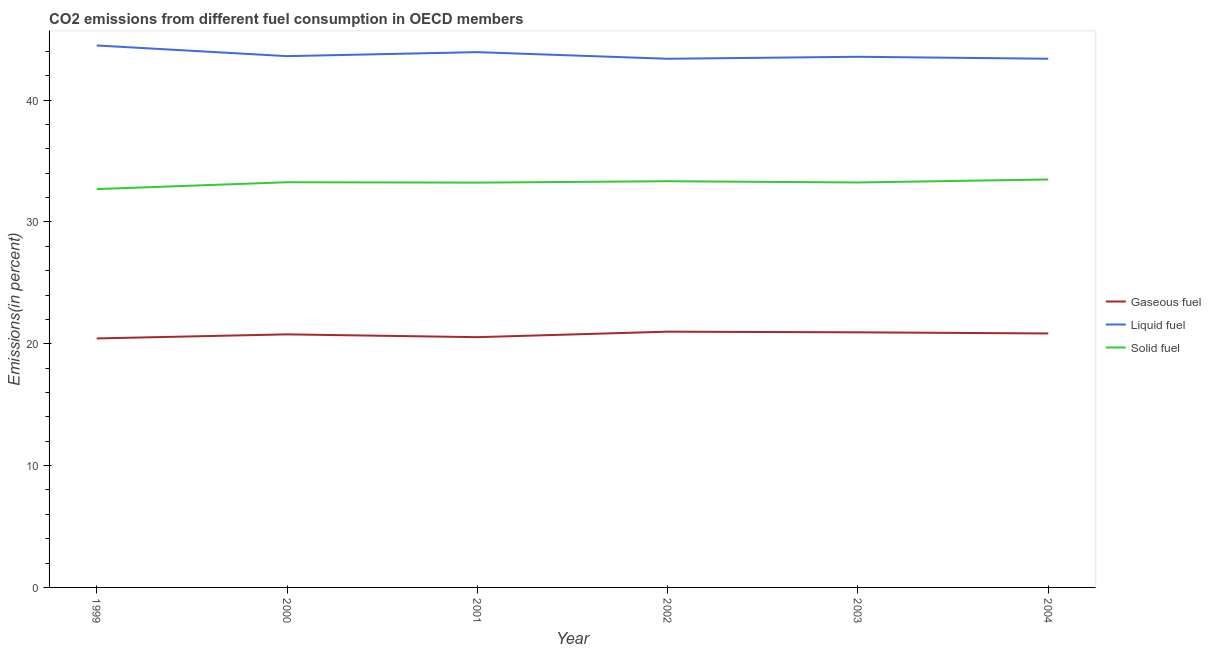What is the percentage of liquid fuel emission in 2002?
Your answer should be compact. 43.39. Across all years, what is the maximum percentage of solid fuel emission?
Offer a very short reply. 33.48. Across all years, what is the minimum percentage of liquid fuel emission?
Your response must be concise. 43.39. In which year was the percentage of solid fuel emission maximum?
Give a very brief answer. 2004. What is the total percentage of liquid fuel emission in the graph?
Keep it short and to the point. 262.35. What is the difference between the percentage of solid fuel emission in 2002 and that in 2003?
Keep it short and to the point. 0.1. What is the difference between the percentage of solid fuel emission in 2001 and the percentage of liquid fuel emission in 2002?
Offer a terse response. -10.17. What is the average percentage of gaseous fuel emission per year?
Provide a short and direct response. 20.75. In the year 1999, what is the difference between the percentage of liquid fuel emission and percentage of gaseous fuel emission?
Provide a short and direct response. 24.04. In how many years, is the percentage of liquid fuel emission greater than 14 %?
Ensure brevity in your answer.  6. What is the ratio of the percentage of liquid fuel emission in 2002 to that in 2003?
Offer a terse response. 1. Is the percentage of solid fuel emission in 2001 less than that in 2003?
Provide a short and direct response. Yes. What is the difference between the highest and the second highest percentage of solid fuel emission?
Your answer should be very brief. 0.14. What is the difference between the highest and the lowest percentage of solid fuel emission?
Ensure brevity in your answer.  0.79. In how many years, is the percentage of solid fuel emission greater than the average percentage of solid fuel emission taken over all years?
Provide a succinct answer. 5. Is it the case that in every year, the sum of the percentage of gaseous fuel emission and percentage of liquid fuel emission is greater than the percentage of solid fuel emission?
Your answer should be very brief. Yes. Does the percentage of solid fuel emission monotonically increase over the years?
Your answer should be very brief. No. Is the percentage of solid fuel emission strictly greater than the percentage of gaseous fuel emission over the years?
Keep it short and to the point. Yes. How many lines are there?
Give a very brief answer. 3. How many years are there in the graph?
Make the answer very short. 6. How are the legend labels stacked?
Provide a succinct answer. Vertical. What is the title of the graph?
Give a very brief answer. CO2 emissions from different fuel consumption in OECD members. Does "Ages 15-64" appear as one of the legend labels in the graph?
Your answer should be very brief. No. What is the label or title of the X-axis?
Offer a very short reply. Year. What is the label or title of the Y-axis?
Provide a succinct answer. Emissions(in percent). What is the Emissions(in percent) in Gaseous fuel in 1999?
Your response must be concise. 20.44. What is the Emissions(in percent) in Liquid fuel in 1999?
Your answer should be very brief. 44.48. What is the Emissions(in percent) of Solid fuel in 1999?
Ensure brevity in your answer.  32.69. What is the Emissions(in percent) in Gaseous fuel in 2000?
Ensure brevity in your answer.  20.77. What is the Emissions(in percent) of Liquid fuel in 2000?
Offer a terse response. 43.61. What is the Emissions(in percent) in Solid fuel in 2000?
Ensure brevity in your answer.  33.26. What is the Emissions(in percent) in Gaseous fuel in 2001?
Your answer should be compact. 20.54. What is the Emissions(in percent) in Liquid fuel in 2001?
Provide a succinct answer. 43.93. What is the Emissions(in percent) in Solid fuel in 2001?
Give a very brief answer. 33.22. What is the Emissions(in percent) in Gaseous fuel in 2002?
Your answer should be very brief. 20.99. What is the Emissions(in percent) of Liquid fuel in 2002?
Provide a short and direct response. 43.39. What is the Emissions(in percent) in Solid fuel in 2002?
Your answer should be compact. 33.34. What is the Emissions(in percent) in Gaseous fuel in 2003?
Provide a short and direct response. 20.94. What is the Emissions(in percent) of Liquid fuel in 2003?
Keep it short and to the point. 43.55. What is the Emissions(in percent) of Solid fuel in 2003?
Your answer should be very brief. 33.24. What is the Emissions(in percent) in Gaseous fuel in 2004?
Keep it short and to the point. 20.84. What is the Emissions(in percent) in Liquid fuel in 2004?
Your response must be concise. 43.39. What is the Emissions(in percent) in Solid fuel in 2004?
Your answer should be compact. 33.48. Across all years, what is the maximum Emissions(in percent) of Gaseous fuel?
Your answer should be compact. 20.99. Across all years, what is the maximum Emissions(in percent) of Liquid fuel?
Give a very brief answer. 44.48. Across all years, what is the maximum Emissions(in percent) in Solid fuel?
Make the answer very short. 33.48. Across all years, what is the minimum Emissions(in percent) of Gaseous fuel?
Ensure brevity in your answer.  20.44. Across all years, what is the minimum Emissions(in percent) of Liquid fuel?
Ensure brevity in your answer.  43.39. Across all years, what is the minimum Emissions(in percent) of Solid fuel?
Your answer should be compact. 32.69. What is the total Emissions(in percent) in Gaseous fuel in the graph?
Provide a short and direct response. 124.52. What is the total Emissions(in percent) in Liquid fuel in the graph?
Give a very brief answer. 262.35. What is the total Emissions(in percent) of Solid fuel in the graph?
Provide a succinct answer. 199.23. What is the difference between the Emissions(in percent) in Gaseous fuel in 1999 and that in 2000?
Make the answer very short. -0.33. What is the difference between the Emissions(in percent) of Liquid fuel in 1999 and that in 2000?
Provide a short and direct response. 0.88. What is the difference between the Emissions(in percent) of Solid fuel in 1999 and that in 2000?
Keep it short and to the point. -0.56. What is the difference between the Emissions(in percent) in Gaseous fuel in 1999 and that in 2001?
Offer a terse response. -0.1. What is the difference between the Emissions(in percent) in Liquid fuel in 1999 and that in 2001?
Your response must be concise. 0.55. What is the difference between the Emissions(in percent) of Solid fuel in 1999 and that in 2001?
Offer a terse response. -0.53. What is the difference between the Emissions(in percent) of Gaseous fuel in 1999 and that in 2002?
Offer a very short reply. -0.55. What is the difference between the Emissions(in percent) of Liquid fuel in 1999 and that in 2002?
Provide a succinct answer. 1.09. What is the difference between the Emissions(in percent) of Solid fuel in 1999 and that in 2002?
Make the answer very short. -0.65. What is the difference between the Emissions(in percent) in Gaseous fuel in 1999 and that in 2003?
Offer a very short reply. -0.5. What is the difference between the Emissions(in percent) in Solid fuel in 1999 and that in 2003?
Provide a succinct answer. -0.54. What is the difference between the Emissions(in percent) in Gaseous fuel in 1999 and that in 2004?
Offer a very short reply. -0.41. What is the difference between the Emissions(in percent) in Liquid fuel in 1999 and that in 2004?
Your answer should be very brief. 1.09. What is the difference between the Emissions(in percent) of Solid fuel in 1999 and that in 2004?
Offer a very short reply. -0.79. What is the difference between the Emissions(in percent) of Gaseous fuel in 2000 and that in 2001?
Your response must be concise. 0.23. What is the difference between the Emissions(in percent) of Liquid fuel in 2000 and that in 2001?
Provide a short and direct response. -0.33. What is the difference between the Emissions(in percent) in Gaseous fuel in 2000 and that in 2002?
Offer a very short reply. -0.22. What is the difference between the Emissions(in percent) in Liquid fuel in 2000 and that in 2002?
Your answer should be compact. 0.22. What is the difference between the Emissions(in percent) of Solid fuel in 2000 and that in 2002?
Offer a very short reply. -0.08. What is the difference between the Emissions(in percent) of Gaseous fuel in 2000 and that in 2003?
Your answer should be compact. -0.17. What is the difference between the Emissions(in percent) in Liquid fuel in 2000 and that in 2003?
Ensure brevity in your answer.  0.05. What is the difference between the Emissions(in percent) of Solid fuel in 2000 and that in 2003?
Offer a terse response. 0.02. What is the difference between the Emissions(in percent) of Gaseous fuel in 2000 and that in 2004?
Your answer should be very brief. -0.07. What is the difference between the Emissions(in percent) of Liquid fuel in 2000 and that in 2004?
Your answer should be compact. 0.21. What is the difference between the Emissions(in percent) in Solid fuel in 2000 and that in 2004?
Give a very brief answer. -0.22. What is the difference between the Emissions(in percent) of Gaseous fuel in 2001 and that in 2002?
Your answer should be compact. -0.45. What is the difference between the Emissions(in percent) in Liquid fuel in 2001 and that in 2002?
Keep it short and to the point. 0.54. What is the difference between the Emissions(in percent) of Solid fuel in 2001 and that in 2002?
Give a very brief answer. -0.12. What is the difference between the Emissions(in percent) in Gaseous fuel in 2001 and that in 2003?
Keep it short and to the point. -0.4. What is the difference between the Emissions(in percent) in Liquid fuel in 2001 and that in 2003?
Offer a very short reply. 0.38. What is the difference between the Emissions(in percent) of Solid fuel in 2001 and that in 2003?
Make the answer very short. -0.01. What is the difference between the Emissions(in percent) in Gaseous fuel in 2001 and that in 2004?
Make the answer very short. -0.31. What is the difference between the Emissions(in percent) in Liquid fuel in 2001 and that in 2004?
Provide a succinct answer. 0.54. What is the difference between the Emissions(in percent) of Solid fuel in 2001 and that in 2004?
Offer a very short reply. -0.26. What is the difference between the Emissions(in percent) of Gaseous fuel in 2002 and that in 2003?
Provide a short and direct response. 0.05. What is the difference between the Emissions(in percent) in Liquid fuel in 2002 and that in 2003?
Offer a terse response. -0.16. What is the difference between the Emissions(in percent) of Solid fuel in 2002 and that in 2003?
Provide a short and direct response. 0.1. What is the difference between the Emissions(in percent) of Gaseous fuel in 2002 and that in 2004?
Make the answer very short. 0.15. What is the difference between the Emissions(in percent) in Liquid fuel in 2002 and that in 2004?
Offer a terse response. -0. What is the difference between the Emissions(in percent) in Solid fuel in 2002 and that in 2004?
Make the answer very short. -0.14. What is the difference between the Emissions(in percent) in Gaseous fuel in 2003 and that in 2004?
Your response must be concise. 0.09. What is the difference between the Emissions(in percent) of Liquid fuel in 2003 and that in 2004?
Give a very brief answer. 0.16. What is the difference between the Emissions(in percent) of Solid fuel in 2003 and that in 2004?
Provide a succinct answer. -0.25. What is the difference between the Emissions(in percent) of Gaseous fuel in 1999 and the Emissions(in percent) of Liquid fuel in 2000?
Offer a terse response. -23.17. What is the difference between the Emissions(in percent) of Gaseous fuel in 1999 and the Emissions(in percent) of Solid fuel in 2000?
Offer a very short reply. -12.82. What is the difference between the Emissions(in percent) of Liquid fuel in 1999 and the Emissions(in percent) of Solid fuel in 2000?
Provide a succinct answer. 11.22. What is the difference between the Emissions(in percent) of Gaseous fuel in 1999 and the Emissions(in percent) of Liquid fuel in 2001?
Your answer should be compact. -23.5. What is the difference between the Emissions(in percent) in Gaseous fuel in 1999 and the Emissions(in percent) in Solid fuel in 2001?
Offer a very short reply. -12.79. What is the difference between the Emissions(in percent) in Liquid fuel in 1999 and the Emissions(in percent) in Solid fuel in 2001?
Your response must be concise. 11.26. What is the difference between the Emissions(in percent) of Gaseous fuel in 1999 and the Emissions(in percent) of Liquid fuel in 2002?
Your answer should be compact. -22.95. What is the difference between the Emissions(in percent) in Gaseous fuel in 1999 and the Emissions(in percent) in Solid fuel in 2002?
Your answer should be very brief. -12.9. What is the difference between the Emissions(in percent) of Liquid fuel in 1999 and the Emissions(in percent) of Solid fuel in 2002?
Provide a succinct answer. 11.14. What is the difference between the Emissions(in percent) in Gaseous fuel in 1999 and the Emissions(in percent) in Liquid fuel in 2003?
Your response must be concise. -23.12. What is the difference between the Emissions(in percent) of Gaseous fuel in 1999 and the Emissions(in percent) of Solid fuel in 2003?
Offer a terse response. -12.8. What is the difference between the Emissions(in percent) in Liquid fuel in 1999 and the Emissions(in percent) in Solid fuel in 2003?
Offer a very short reply. 11.24. What is the difference between the Emissions(in percent) of Gaseous fuel in 1999 and the Emissions(in percent) of Liquid fuel in 2004?
Provide a short and direct response. -22.96. What is the difference between the Emissions(in percent) of Gaseous fuel in 1999 and the Emissions(in percent) of Solid fuel in 2004?
Offer a terse response. -13.05. What is the difference between the Emissions(in percent) in Liquid fuel in 1999 and the Emissions(in percent) in Solid fuel in 2004?
Offer a very short reply. 11. What is the difference between the Emissions(in percent) in Gaseous fuel in 2000 and the Emissions(in percent) in Liquid fuel in 2001?
Provide a short and direct response. -23.16. What is the difference between the Emissions(in percent) in Gaseous fuel in 2000 and the Emissions(in percent) in Solid fuel in 2001?
Your answer should be compact. -12.45. What is the difference between the Emissions(in percent) in Liquid fuel in 2000 and the Emissions(in percent) in Solid fuel in 2001?
Ensure brevity in your answer.  10.38. What is the difference between the Emissions(in percent) of Gaseous fuel in 2000 and the Emissions(in percent) of Liquid fuel in 2002?
Provide a succinct answer. -22.62. What is the difference between the Emissions(in percent) in Gaseous fuel in 2000 and the Emissions(in percent) in Solid fuel in 2002?
Offer a terse response. -12.57. What is the difference between the Emissions(in percent) in Liquid fuel in 2000 and the Emissions(in percent) in Solid fuel in 2002?
Ensure brevity in your answer.  10.27. What is the difference between the Emissions(in percent) of Gaseous fuel in 2000 and the Emissions(in percent) of Liquid fuel in 2003?
Your answer should be very brief. -22.78. What is the difference between the Emissions(in percent) of Gaseous fuel in 2000 and the Emissions(in percent) of Solid fuel in 2003?
Offer a very short reply. -12.47. What is the difference between the Emissions(in percent) of Liquid fuel in 2000 and the Emissions(in percent) of Solid fuel in 2003?
Give a very brief answer. 10.37. What is the difference between the Emissions(in percent) of Gaseous fuel in 2000 and the Emissions(in percent) of Liquid fuel in 2004?
Your response must be concise. -22.62. What is the difference between the Emissions(in percent) in Gaseous fuel in 2000 and the Emissions(in percent) in Solid fuel in 2004?
Your answer should be very brief. -12.71. What is the difference between the Emissions(in percent) in Liquid fuel in 2000 and the Emissions(in percent) in Solid fuel in 2004?
Offer a very short reply. 10.12. What is the difference between the Emissions(in percent) of Gaseous fuel in 2001 and the Emissions(in percent) of Liquid fuel in 2002?
Your answer should be very brief. -22.85. What is the difference between the Emissions(in percent) of Gaseous fuel in 2001 and the Emissions(in percent) of Solid fuel in 2002?
Give a very brief answer. -12.8. What is the difference between the Emissions(in percent) in Liquid fuel in 2001 and the Emissions(in percent) in Solid fuel in 2002?
Provide a short and direct response. 10.59. What is the difference between the Emissions(in percent) in Gaseous fuel in 2001 and the Emissions(in percent) in Liquid fuel in 2003?
Offer a terse response. -23.01. What is the difference between the Emissions(in percent) in Gaseous fuel in 2001 and the Emissions(in percent) in Solid fuel in 2003?
Keep it short and to the point. -12.7. What is the difference between the Emissions(in percent) of Liquid fuel in 2001 and the Emissions(in percent) of Solid fuel in 2003?
Keep it short and to the point. 10.7. What is the difference between the Emissions(in percent) of Gaseous fuel in 2001 and the Emissions(in percent) of Liquid fuel in 2004?
Offer a terse response. -22.85. What is the difference between the Emissions(in percent) in Gaseous fuel in 2001 and the Emissions(in percent) in Solid fuel in 2004?
Offer a very short reply. -12.94. What is the difference between the Emissions(in percent) of Liquid fuel in 2001 and the Emissions(in percent) of Solid fuel in 2004?
Make the answer very short. 10.45. What is the difference between the Emissions(in percent) of Gaseous fuel in 2002 and the Emissions(in percent) of Liquid fuel in 2003?
Keep it short and to the point. -22.56. What is the difference between the Emissions(in percent) in Gaseous fuel in 2002 and the Emissions(in percent) in Solid fuel in 2003?
Your answer should be very brief. -12.25. What is the difference between the Emissions(in percent) in Liquid fuel in 2002 and the Emissions(in percent) in Solid fuel in 2003?
Give a very brief answer. 10.15. What is the difference between the Emissions(in percent) in Gaseous fuel in 2002 and the Emissions(in percent) in Liquid fuel in 2004?
Offer a very short reply. -22.4. What is the difference between the Emissions(in percent) in Gaseous fuel in 2002 and the Emissions(in percent) in Solid fuel in 2004?
Provide a short and direct response. -12.49. What is the difference between the Emissions(in percent) in Liquid fuel in 2002 and the Emissions(in percent) in Solid fuel in 2004?
Give a very brief answer. 9.91. What is the difference between the Emissions(in percent) in Gaseous fuel in 2003 and the Emissions(in percent) in Liquid fuel in 2004?
Keep it short and to the point. -22.46. What is the difference between the Emissions(in percent) of Gaseous fuel in 2003 and the Emissions(in percent) of Solid fuel in 2004?
Your answer should be compact. -12.54. What is the difference between the Emissions(in percent) in Liquid fuel in 2003 and the Emissions(in percent) in Solid fuel in 2004?
Keep it short and to the point. 10.07. What is the average Emissions(in percent) of Gaseous fuel per year?
Make the answer very short. 20.75. What is the average Emissions(in percent) of Liquid fuel per year?
Offer a very short reply. 43.73. What is the average Emissions(in percent) in Solid fuel per year?
Your response must be concise. 33.21. In the year 1999, what is the difference between the Emissions(in percent) of Gaseous fuel and Emissions(in percent) of Liquid fuel?
Ensure brevity in your answer.  -24.04. In the year 1999, what is the difference between the Emissions(in percent) of Gaseous fuel and Emissions(in percent) of Solid fuel?
Keep it short and to the point. -12.26. In the year 1999, what is the difference between the Emissions(in percent) of Liquid fuel and Emissions(in percent) of Solid fuel?
Provide a succinct answer. 11.79. In the year 2000, what is the difference between the Emissions(in percent) of Gaseous fuel and Emissions(in percent) of Liquid fuel?
Keep it short and to the point. -22.84. In the year 2000, what is the difference between the Emissions(in percent) of Gaseous fuel and Emissions(in percent) of Solid fuel?
Ensure brevity in your answer.  -12.49. In the year 2000, what is the difference between the Emissions(in percent) in Liquid fuel and Emissions(in percent) in Solid fuel?
Offer a very short reply. 10.35. In the year 2001, what is the difference between the Emissions(in percent) of Gaseous fuel and Emissions(in percent) of Liquid fuel?
Keep it short and to the point. -23.39. In the year 2001, what is the difference between the Emissions(in percent) in Gaseous fuel and Emissions(in percent) in Solid fuel?
Provide a short and direct response. -12.68. In the year 2001, what is the difference between the Emissions(in percent) of Liquid fuel and Emissions(in percent) of Solid fuel?
Provide a succinct answer. 10.71. In the year 2002, what is the difference between the Emissions(in percent) of Gaseous fuel and Emissions(in percent) of Liquid fuel?
Provide a short and direct response. -22.4. In the year 2002, what is the difference between the Emissions(in percent) of Gaseous fuel and Emissions(in percent) of Solid fuel?
Your answer should be very brief. -12.35. In the year 2002, what is the difference between the Emissions(in percent) of Liquid fuel and Emissions(in percent) of Solid fuel?
Your answer should be compact. 10.05. In the year 2003, what is the difference between the Emissions(in percent) in Gaseous fuel and Emissions(in percent) in Liquid fuel?
Provide a short and direct response. -22.62. In the year 2003, what is the difference between the Emissions(in percent) in Gaseous fuel and Emissions(in percent) in Solid fuel?
Offer a very short reply. -12.3. In the year 2003, what is the difference between the Emissions(in percent) in Liquid fuel and Emissions(in percent) in Solid fuel?
Offer a very short reply. 10.32. In the year 2004, what is the difference between the Emissions(in percent) of Gaseous fuel and Emissions(in percent) of Liquid fuel?
Offer a terse response. -22.55. In the year 2004, what is the difference between the Emissions(in percent) of Gaseous fuel and Emissions(in percent) of Solid fuel?
Keep it short and to the point. -12.64. In the year 2004, what is the difference between the Emissions(in percent) in Liquid fuel and Emissions(in percent) in Solid fuel?
Ensure brevity in your answer.  9.91. What is the ratio of the Emissions(in percent) in Gaseous fuel in 1999 to that in 2000?
Give a very brief answer. 0.98. What is the ratio of the Emissions(in percent) in Liquid fuel in 1999 to that in 2000?
Make the answer very short. 1.02. What is the ratio of the Emissions(in percent) of Solid fuel in 1999 to that in 2000?
Give a very brief answer. 0.98. What is the ratio of the Emissions(in percent) of Gaseous fuel in 1999 to that in 2001?
Your answer should be very brief. 0.99. What is the ratio of the Emissions(in percent) of Liquid fuel in 1999 to that in 2001?
Provide a short and direct response. 1.01. What is the ratio of the Emissions(in percent) of Solid fuel in 1999 to that in 2001?
Provide a succinct answer. 0.98. What is the ratio of the Emissions(in percent) in Gaseous fuel in 1999 to that in 2002?
Ensure brevity in your answer.  0.97. What is the ratio of the Emissions(in percent) of Liquid fuel in 1999 to that in 2002?
Ensure brevity in your answer.  1.03. What is the ratio of the Emissions(in percent) of Solid fuel in 1999 to that in 2002?
Offer a terse response. 0.98. What is the ratio of the Emissions(in percent) of Gaseous fuel in 1999 to that in 2003?
Keep it short and to the point. 0.98. What is the ratio of the Emissions(in percent) in Liquid fuel in 1999 to that in 2003?
Ensure brevity in your answer.  1.02. What is the ratio of the Emissions(in percent) in Solid fuel in 1999 to that in 2003?
Provide a short and direct response. 0.98. What is the ratio of the Emissions(in percent) of Gaseous fuel in 1999 to that in 2004?
Your response must be concise. 0.98. What is the ratio of the Emissions(in percent) in Liquid fuel in 1999 to that in 2004?
Make the answer very short. 1.03. What is the ratio of the Emissions(in percent) of Solid fuel in 1999 to that in 2004?
Keep it short and to the point. 0.98. What is the ratio of the Emissions(in percent) in Gaseous fuel in 2000 to that in 2001?
Provide a succinct answer. 1.01. What is the ratio of the Emissions(in percent) in Liquid fuel in 2000 to that in 2001?
Ensure brevity in your answer.  0.99. What is the ratio of the Emissions(in percent) of Gaseous fuel in 2000 to that in 2002?
Your answer should be very brief. 0.99. What is the ratio of the Emissions(in percent) of Liquid fuel in 2000 to that in 2002?
Keep it short and to the point. 1. What is the ratio of the Emissions(in percent) in Liquid fuel in 2000 to that in 2003?
Your answer should be compact. 1. What is the ratio of the Emissions(in percent) in Solid fuel in 2000 to that in 2003?
Your answer should be compact. 1. What is the ratio of the Emissions(in percent) in Liquid fuel in 2000 to that in 2004?
Make the answer very short. 1. What is the ratio of the Emissions(in percent) of Gaseous fuel in 2001 to that in 2002?
Provide a short and direct response. 0.98. What is the ratio of the Emissions(in percent) of Liquid fuel in 2001 to that in 2002?
Keep it short and to the point. 1.01. What is the ratio of the Emissions(in percent) in Liquid fuel in 2001 to that in 2003?
Offer a terse response. 1.01. What is the ratio of the Emissions(in percent) in Solid fuel in 2001 to that in 2003?
Offer a very short reply. 1. What is the ratio of the Emissions(in percent) in Gaseous fuel in 2001 to that in 2004?
Your response must be concise. 0.99. What is the ratio of the Emissions(in percent) of Liquid fuel in 2001 to that in 2004?
Your response must be concise. 1.01. What is the ratio of the Emissions(in percent) of Solid fuel in 2001 to that in 2004?
Provide a succinct answer. 0.99. What is the ratio of the Emissions(in percent) in Gaseous fuel in 2002 to that in 2003?
Offer a very short reply. 1. What is the ratio of the Emissions(in percent) in Liquid fuel in 2002 to that in 2004?
Provide a short and direct response. 1. What is the ratio of the Emissions(in percent) in Solid fuel in 2003 to that in 2004?
Keep it short and to the point. 0.99. What is the difference between the highest and the second highest Emissions(in percent) of Gaseous fuel?
Your answer should be very brief. 0.05. What is the difference between the highest and the second highest Emissions(in percent) of Liquid fuel?
Provide a succinct answer. 0.55. What is the difference between the highest and the second highest Emissions(in percent) in Solid fuel?
Provide a short and direct response. 0.14. What is the difference between the highest and the lowest Emissions(in percent) of Gaseous fuel?
Your answer should be compact. 0.55. What is the difference between the highest and the lowest Emissions(in percent) in Liquid fuel?
Your response must be concise. 1.09. What is the difference between the highest and the lowest Emissions(in percent) in Solid fuel?
Make the answer very short. 0.79. 